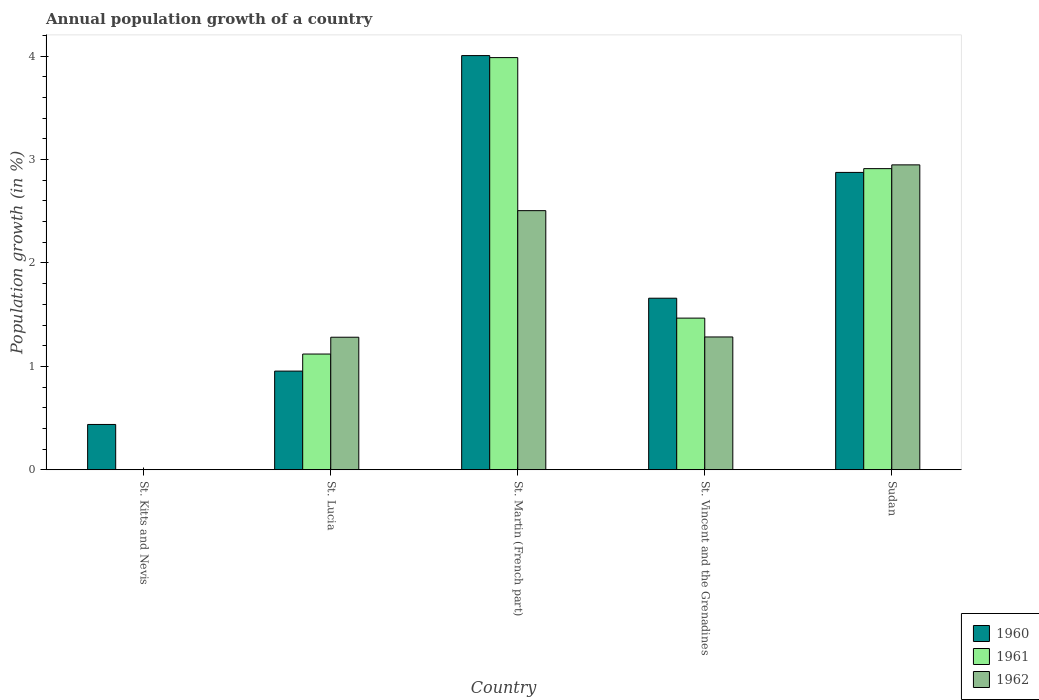What is the label of the 5th group of bars from the left?
Make the answer very short. Sudan. What is the annual population growth in 1962 in St. Martin (French part)?
Keep it short and to the point. 2.51. Across all countries, what is the maximum annual population growth in 1962?
Offer a terse response. 2.95. In which country was the annual population growth in 1962 maximum?
Make the answer very short. Sudan. What is the total annual population growth in 1961 in the graph?
Ensure brevity in your answer.  9.48. What is the difference between the annual population growth in 1961 in St. Lucia and that in Sudan?
Keep it short and to the point. -1.79. What is the difference between the annual population growth in 1961 in St. Kitts and Nevis and the annual population growth in 1962 in Sudan?
Provide a succinct answer. -2.95. What is the average annual population growth in 1960 per country?
Your answer should be very brief. 1.99. What is the difference between the annual population growth of/in 1961 and annual population growth of/in 1962 in St. Lucia?
Offer a terse response. -0.16. In how many countries, is the annual population growth in 1960 greater than 2.2 %?
Provide a short and direct response. 2. What is the ratio of the annual population growth in 1960 in St. Kitts and Nevis to that in St. Vincent and the Grenadines?
Your answer should be compact. 0.26. What is the difference between the highest and the second highest annual population growth in 1961?
Provide a succinct answer. -1.45. What is the difference between the highest and the lowest annual population growth in 1961?
Offer a very short reply. 3.99. Is the sum of the annual population growth in 1960 in St. Lucia and St. Martin (French part) greater than the maximum annual population growth in 1962 across all countries?
Offer a very short reply. Yes. How many bars are there?
Your answer should be very brief. 13. Are all the bars in the graph horizontal?
Make the answer very short. No. How many countries are there in the graph?
Make the answer very short. 5. What is the difference between two consecutive major ticks on the Y-axis?
Offer a very short reply. 1. Are the values on the major ticks of Y-axis written in scientific E-notation?
Keep it short and to the point. No. Does the graph contain any zero values?
Your answer should be very brief. Yes. Does the graph contain grids?
Ensure brevity in your answer.  No. Where does the legend appear in the graph?
Offer a terse response. Bottom right. How are the legend labels stacked?
Provide a succinct answer. Vertical. What is the title of the graph?
Your answer should be very brief. Annual population growth of a country. Does "2014" appear as one of the legend labels in the graph?
Offer a very short reply. No. What is the label or title of the Y-axis?
Give a very brief answer. Population growth (in %). What is the Population growth (in %) of 1960 in St. Kitts and Nevis?
Offer a terse response. 0.44. What is the Population growth (in %) in 1961 in St. Kitts and Nevis?
Make the answer very short. 0. What is the Population growth (in %) of 1962 in St. Kitts and Nevis?
Make the answer very short. 0. What is the Population growth (in %) of 1960 in St. Lucia?
Your answer should be compact. 0.95. What is the Population growth (in %) in 1961 in St. Lucia?
Offer a very short reply. 1.12. What is the Population growth (in %) of 1962 in St. Lucia?
Make the answer very short. 1.28. What is the Population growth (in %) of 1960 in St. Martin (French part)?
Your answer should be very brief. 4.01. What is the Population growth (in %) in 1961 in St. Martin (French part)?
Provide a short and direct response. 3.99. What is the Population growth (in %) in 1962 in St. Martin (French part)?
Ensure brevity in your answer.  2.51. What is the Population growth (in %) of 1960 in St. Vincent and the Grenadines?
Ensure brevity in your answer.  1.66. What is the Population growth (in %) of 1961 in St. Vincent and the Grenadines?
Give a very brief answer. 1.47. What is the Population growth (in %) in 1962 in St. Vincent and the Grenadines?
Provide a succinct answer. 1.28. What is the Population growth (in %) in 1960 in Sudan?
Provide a succinct answer. 2.88. What is the Population growth (in %) of 1961 in Sudan?
Provide a short and direct response. 2.91. What is the Population growth (in %) of 1962 in Sudan?
Make the answer very short. 2.95. Across all countries, what is the maximum Population growth (in %) in 1960?
Keep it short and to the point. 4.01. Across all countries, what is the maximum Population growth (in %) in 1961?
Keep it short and to the point. 3.99. Across all countries, what is the maximum Population growth (in %) of 1962?
Make the answer very short. 2.95. Across all countries, what is the minimum Population growth (in %) in 1960?
Provide a succinct answer. 0.44. Across all countries, what is the minimum Population growth (in %) of 1961?
Offer a very short reply. 0. What is the total Population growth (in %) of 1960 in the graph?
Provide a short and direct response. 9.93. What is the total Population growth (in %) of 1961 in the graph?
Your answer should be very brief. 9.48. What is the total Population growth (in %) of 1962 in the graph?
Your response must be concise. 8.02. What is the difference between the Population growth (in %) in 1960 in St. Kitts and Nevis and that in St. Lucia?
Offer a very short reply. -0.52. What is the difference between the Population growth (in %) of 1960 in St. Kitts and Nevis and that in St. Martin (French part)?
Your response must be concise. -3.57. What is the difference between the Population growth (in %) of 1960 in St. Kitts and Nevis and that in St. Vincent and the Grenadines?
Your response must be concise. -1.22. What is the difference between the Population growth (in %) in 1960 in St. Kitts and Nevis and that in Sudan?
Offer a terse response. -2.44. What is the difference between the Population growth (in %) in 1960 in St. Lucia and that in St. Martin (French part)?
Provide a short and direct response. -3.05. What is the difference between the Population growth (in %) of 1961 in St. Lucia and that in St. Martin (French part)?
Provide a succinct answer. -2.87. What is the difference between the Population growth (in %) of 1962 in St. Lucia and that in St. Martin (French part)?
Ensure brevity in your answer.  -1.22. What is the difference between the Population growth (in %) of 1960 in St. Lucia and that in St. Vincent and the Grenadines?
Your answer should be very brief. -0.7. What is the difference between the Population growth (in %) in 1961 in St. Lucia and that in St. Vincent and the Grenadines?
Provide a short and direct response. -0.35. What is the difference between the Population growth (in %) in 1962 in St. Lucia and that in St. Vincent and the Grenadines?
Offer a very short reply. -0. What is the difference between the Population growth (in %) in 1960 in St. Lucia and that in Sudan?
Your answer should be compact. -1.92. What is the difference between the Population growth (in %) in 1961 in St. Lucia and that in Sudan?
Your answer should be compact. -1.79. What is the difference between the Population growth (in %) of 1962 in St. Lucia and that in Sudan?
Make the answer very short. -1.67. What is the difference between the Population growth (in %) in 1960 in St. Martin (French part) and that in St. Vincent and the Grenadines?
Keep it short and to the point. 2.35. What is the difference between the Population growth (in %) in 1961 in St. Martin (French part) and that in St. Vincent and the Grenadines?
Make the answer very short. 2.52. What is the difference between the Population growth (in %) of 1962 in St. Martin (French part) and that in St. Vincent and the Grenadines?
Provide a succinct answer. 1.22. What is the difference between the Population growth (in %) of 1960 in St. Martin (French part) and that in Sudan?
Your answer should be compact. 1.13. What is the difference between the Population growth (in %) of 1961 in St. Martin (French part) and that in Sudan?
Ensure brevity in your answer.  1.07. What is the difference between the Population growth (in %) in 1962 in St. Martin (French part) and that in Sudan?
Provide a succinct answer. -0.44. What is the difference between the Population growth (in %) in 1960 in St. Vincent and the Grenadines and that in Sudan?
Provide a short and direct response. -1.22. What is the difference between the Population growth (in %) of 1961 in St. Vincent and the Grenadines and that in Sudan?
Keep it short and to the point. -1.45. What is the difference between the Population growth (in %) in 1962 in St. Vincent and the Grenadines and that in Sudan?
Offer a terse response. -1.66. What is the difference between the Population growth (in %) of 1960 in St. Kitts and Nevis and the Population growth (in %) of 1961 in St. Lucia?
Make the answer very short. -0.68. What is the difference between the Population growth (in %) of 1960 in St. Kitts and Nevis and the Population growth (in %) of 1962 in St. Lucia?
Your response must be concise. -0.84. What is the difference between the Population growth (in %) of 1960 in St. Kitts and Nevis and the Population growth (in %) of 1961 in St. Martin (French part)?
Your answer should be compact. -3.55. What is the difference between the Population growth (in %) in 1960 in St. Kitts and Nevis and the Population growth (in %) in 1962 in St. Martin (French part)?
Make the answer very short. -2.07. What is the difference between the Population growth (in %) of 1960 in St. Kitts and Nevis and the Population growth (in %) of 1961 in St. Vincent and the Grenadines?
Offer a terse response. -1.03. What is the difference between the Population growth (in %) of 1960 in St. Kitts and Nevis and the Population growth (in %) of 1962 in St. Vincent and the Grenadines?
Make the answer very short. -0.85. What is the difference between the Population growth (in %) of 1960 in St. Kitts and Nevis and the Population growth (in %) of 1961 in Sudan?
Offer a very short reply. -2.47. What is the difference between the Population growth (in %) of 1960 in St. Kitts and Nevis and the Population growth (in %) of 1962 in Sudan?
Your response must be concise. -2.51. What is the difference between the Population growth (in %) of 1960 in St. Lucia and the Population growth (in %) of 1961 in St. Martin (French part)?
Offer a very short reply. -3.03. What is the difference between the Population growth (in %) of 1960 in St. Lucia and the Population growth (in %) of 1962 in St. Martin (French part)?
Provide a succinct answer. -1.55. What is the difference between the Population growth (in %) in 1961 in St. Lucia and the Population growth (in %) in 1962 in St. Martin (French part)?
Give a very brief answer. -1.39. What is the difference between the Population growth (in %) in 1960 in St. Lucia and the Population growth (in %) in 1961 in St. Vincent and the Grenadines?
Ensure brevity in your answer.  -0.51. What is the difference between the Population growth (in %) of 1960 in St. Lucia and the Population growth (in %) of 1962 in St. Vincent and the Grenadines?
Provide a succinct answer. -0.33. What is the difference between the Population growth (in %) of 1961 in St. Lucia and the Population growth (in %) of 1962 in St. Vincent and the Grenadines?
Offer a terse response. -0.17. What is the difference between the Population growth (in %) in 1960 in St. Lucia and the Population growth (in %) in 1961 in Sudan?
Your answer should be compact. -1.96. What is the difference between the Population growth (in %) of 1960 in St. Lucia and the Population growth (in %) of 1962 in Sudan?
Your answer should be very brief. -1.99. What is the difference between the Population growth (in %) in 1961 in St. Lucia and the Population growth (in %) in 1962 in Sudan?
Give a very brief answer. -1.83. What is the difference between the Population growth (in %) of 1960 in St. Martin (French part) and the Population growth (in %) of 1961 in St. Vincent and the Grenadines?
Give a very brief answer. 2.54. What is the difference between the Population growth (in %) in 1960 in St. Martin (French part) and the Population growth (in %) in 1962 in St. Vincent and the Grenadines?
Offer a terse response. 2.72. What is the difference between the Population growth (in %) in 1961 in St. Martin (French part) and the Population growth (in %) in 1962 in St. Vincent and the Grenadines?
Give a very brief answer. 2.7. What is the difference between the Population growth (in %) of 1960 in St. Martin (French part) and the Population growth (in %) of 1961 in Sudan?
Provide a succinct answer. 1.09. What is the difference between the Population growth (in %) in 1960 in St. Martin (French part) and the Population growth (in %) in 1962 in Sudan?
Your answer should be very brief. 1.06. What is the difference between the Population growth (in %) in 1961 in St. Martin (French part) and the Population growth (in %) in 1962 in Sudan?
Give a very brief answer. 1.04. What is the difference between the Population growth (in %) in 1960 in St. Vincent and the Grenadines and the Population growth (in %) in 1961 in Sudan?
Provide a short and direct response. -1.25. What is the difference between the Population growth (in %) of 1960 in St. Vincent and the Grenadines and the Population growth (in %) of 1962 in Sudan?
Make the answer very short. -1.29. What is the difference between the Population growth (in %) in 1961 in St. Vincent and the Grenadines and the Population growth (in %) in 1962 in Sudan?
Make the answer very short. -1.48. What is the average Population growth (in %) in 1960 per country?
Make the answer very short. 1.99. What is the average Population growth (in %) in 1961 per country?
Your answer should be compact. 1.9. What is the average Population growth (in %) of 1962 per country?
Keep it short and to the point. 1.6. What is the difference between the Population growth (in %) of 1960 and Population growth (in %) of 1961 in St. Lucia?
Keep it short and to the point. -0.16. What is the difference between the Population growth (in %) of 1960 and Population growth (in %) of 1962 in St. Lucia?
Make the answer very short. -0.33. What is the difference between the Population growth (in %) in 1961 and Population growth (in %) in 1962 in St. Lucia?
Keep it short and to the point. -0.16. What is the difference between the Population growth (in %) of 1960 and Population growth (in %) of 1961 in St. Martin (French part)?
Your answer should be very brief. 0.02. What is the difference between the Population growth (in %) in 1960 and Population growth (in %) in 1962 in St. Martin (French part)?
Ensure brevity in your answer.  1.5. What is the difference between the Population growth (in %) of 1961 and Population growth (in %) of 1962 in St. Martin (French part)?
Offer a terse response. 1.48. What is the difference between the Population growth (in %) in 1960 and Population growth (in %) in 1961 in St. Vincent and the Grenadines?
Make the answer very short. 0.19. What is the difference between the Population growth (in %) of 1960 and Population growth (in %) of 1962 in St. Vincent and the Grenadines?
Your answer should be very brief. 0.37. What is the difference between the Population growth (in %) of 1961 and Population growth (in %) of 1962 in St. Vincent and the Grenadines?
Provide a short and direct response. 0.18. What is the difference between the Population growth (in %) in 1960 and Population growth (in %) in 1961 in Sudan?
Keep it short and to the point. -0.04. What is the difference between the Population growth (in %) of 1960 and Population growth (in %) of 1962 in Sudan?
Provide a short and direct response. -0.07. What is the difference between the Population growth (in %) of 1961 and Population growth (in %) of 1962 in Sudan?
Keep it short and to the point. -0.04. What is the ratio of the Population growth (in %) in 1960 in St. Kitts and Nevis to that in St. Lucia?
Offer a terse response. 0.46. What is the ratio of the Population growth (in %) of 1960 in St. Kitts and Nevis to that in St. Martin (French part)?
Your answer should be very brief. 0.11. What is the ratio of the Population growth (in %) of 1960 in St. Kitts and Nevis to that in St. Vincent and the Grenadines?
Provide a short and direct response. 0.26. What is the ratio of the Population growth (in %) in 1960 in St. Kitts and Nevis to that in Sudan?
Your answer should be very brief. 0.15. What is the ratio of the Population growth (in %) in 1960 in St. Lucia to that in St. Martin (French part)?
Offer a very short reply. 0.24. What is the ratio of the Population growth (in %) of 1961 in St. Lucia to that in St. Martin (French part)?
Make the answer very short. 0.28. What is the ratio of the Population growth (in %) in 1962 in St. Lucia to that in St. Martin (French part)?
Your response must be concise. 0.51. What is the ratio of the Population growth (in %) of 1960 in St. Lucia to that in St. Vincent and the Grenadines?
Your response must be concise. 0.58. What is the ratio of the Population growth (in %) in 1961 in St. Lucia to that in St. Vincent and the Grenadines?
Offer a very short reply. 0.76. What is the ratio of the Population growth (in %) in 1960 in St. Lucia to that in Sudan?
Offer a terse response. 0.33. What is the ratio of the Population growth (in %) of 1961 in St. Lucia to that in Sudan?
Keep it short and to the point. 0.38. What is the ratio of the Population growth (in %) in 1962 in St. Lucia to that in Sudan?
Your answer should be compact. 0.43. What is the ratio of the Population growth (in %) of 1960 in St. Martin (French part) to that in St. Vincent and the Grenadines?
Your answer should be very brief. 2.41. What is the ratio of the Population growth (in %) in 1961 in St. Martin (French part) to that in St. Vincent and the Grenadines?
Ensure brevity in your answer.  2.72. What is the ratio of the Population growth (in %) of 1962 in St. Martin (French part) to that in St. Vincent and the Grenadines?
Give a very brief answer. 1.95. What is the ratio of the Population growth (in %) of 1960 in St. Martin (French part) to that in Sudan?
Provide a succinct answer. 1.39. What is the ratio of the Population growth (in %) in 1961 in St. Martin (French part) to that in Sudan?
Your response must be concise. 1.37. What is the ratio of the Population growth (in %) in 1962 in St. Martin (French part) to that in Sudan?
Offer a terse response. 0.85. What is the ratio of the Population growth (in %) in 1960 in St. Vincent and the Grenadines to that in Sudan?
Give a very brief answer. 0.58. What is the ratio of the Population growth (in %) of 1961 in St. Vincent and the Grenadines to that in Sudan?
Offer a terse response. 0.5. What is the ratio of the Population growth (in %) in 1962 in St. Vincent and the Grenadines to that in Sudan?
Your answer should be very brief. 0.44. What is the difference between the highest and the second highest Population growth (in %) of 1960?
Your answer should be very brief. 1.13. What is the difference between the highest and the second highest Population growth (in %) in 1961?
Your answer should be very brief. 1.07. What is the difference between the highest and the second highest Population growth (in %) in 1962?
Provide a short and direct response. 0.44. What is the difference between the highest and the lowest Population growth (in %) in 1960?
Ensure brevity in your answer.  3.57. What is the difference between the highest and the lowest Population growth (in %) in 1961?
Ensure brevity in your answer.  3.99. What is the difference between the highest and the lowest Population growth (in %) of 1962?
Make the answer very short. 2.95. 